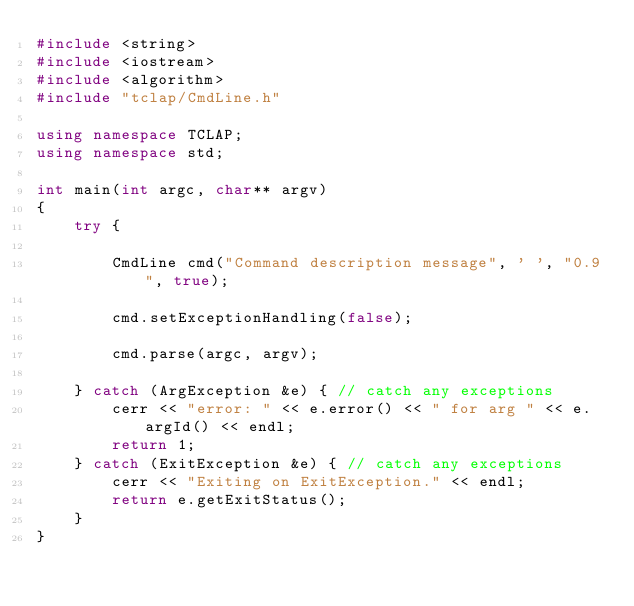Convert code to text. <code><loc_0><loc_0><loc_500><loc_500><_C++_>#include <string>
#include <iostream>
#include <algorithm>
#include "tclap/CmdLine.h"

using namespace TCLAP;
using namespace std;

int main(int argc, char** argv)
{
	try {

		CmdLine cmd("Command description message", ' ', "0.9", true);

		cmd.setExceptionHandling(false);

		cmd.parse(argc, argv);

	} catch (ArgException &e) { // catch any exceptions
		cerr << "error: " << e.error() << " for arg " << e.argId() << endl;
		return 1;
	} catch (ExitException &e) { // catch any exceptions
		cerr << "Exiting on ExitException." << endl;
		return e.getExitStatus();
	}
}

</code> 